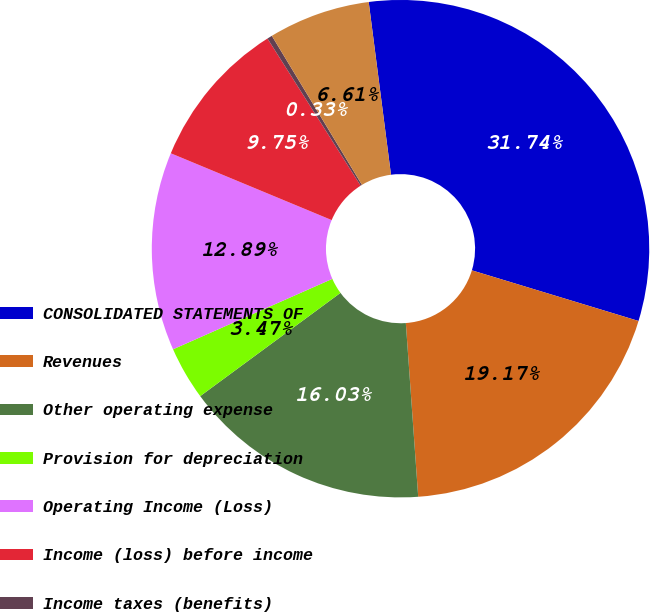Convert chart to OTSL. <chart><loc_0><loc_0><loc_500><loc_500><pie_chart><fcel>CONSOLIDATED STATEMENTS OF<fcel>Revenues<fcel>Other operating expense<fcel>Provision for depreciation<fcel>Operating Income (Loss)<fcel>Income (loss) before income<fcel>Income taxes (benefits)<fcel>Net Income (Loss)<nl><fcel>31.73%<fcel>19.17%<fcel>16.03%<fcel>3.47%<fcel>12.89%<fcel>9.75%<fcel>0.33%<fcel>6.61%<nl></chart> 